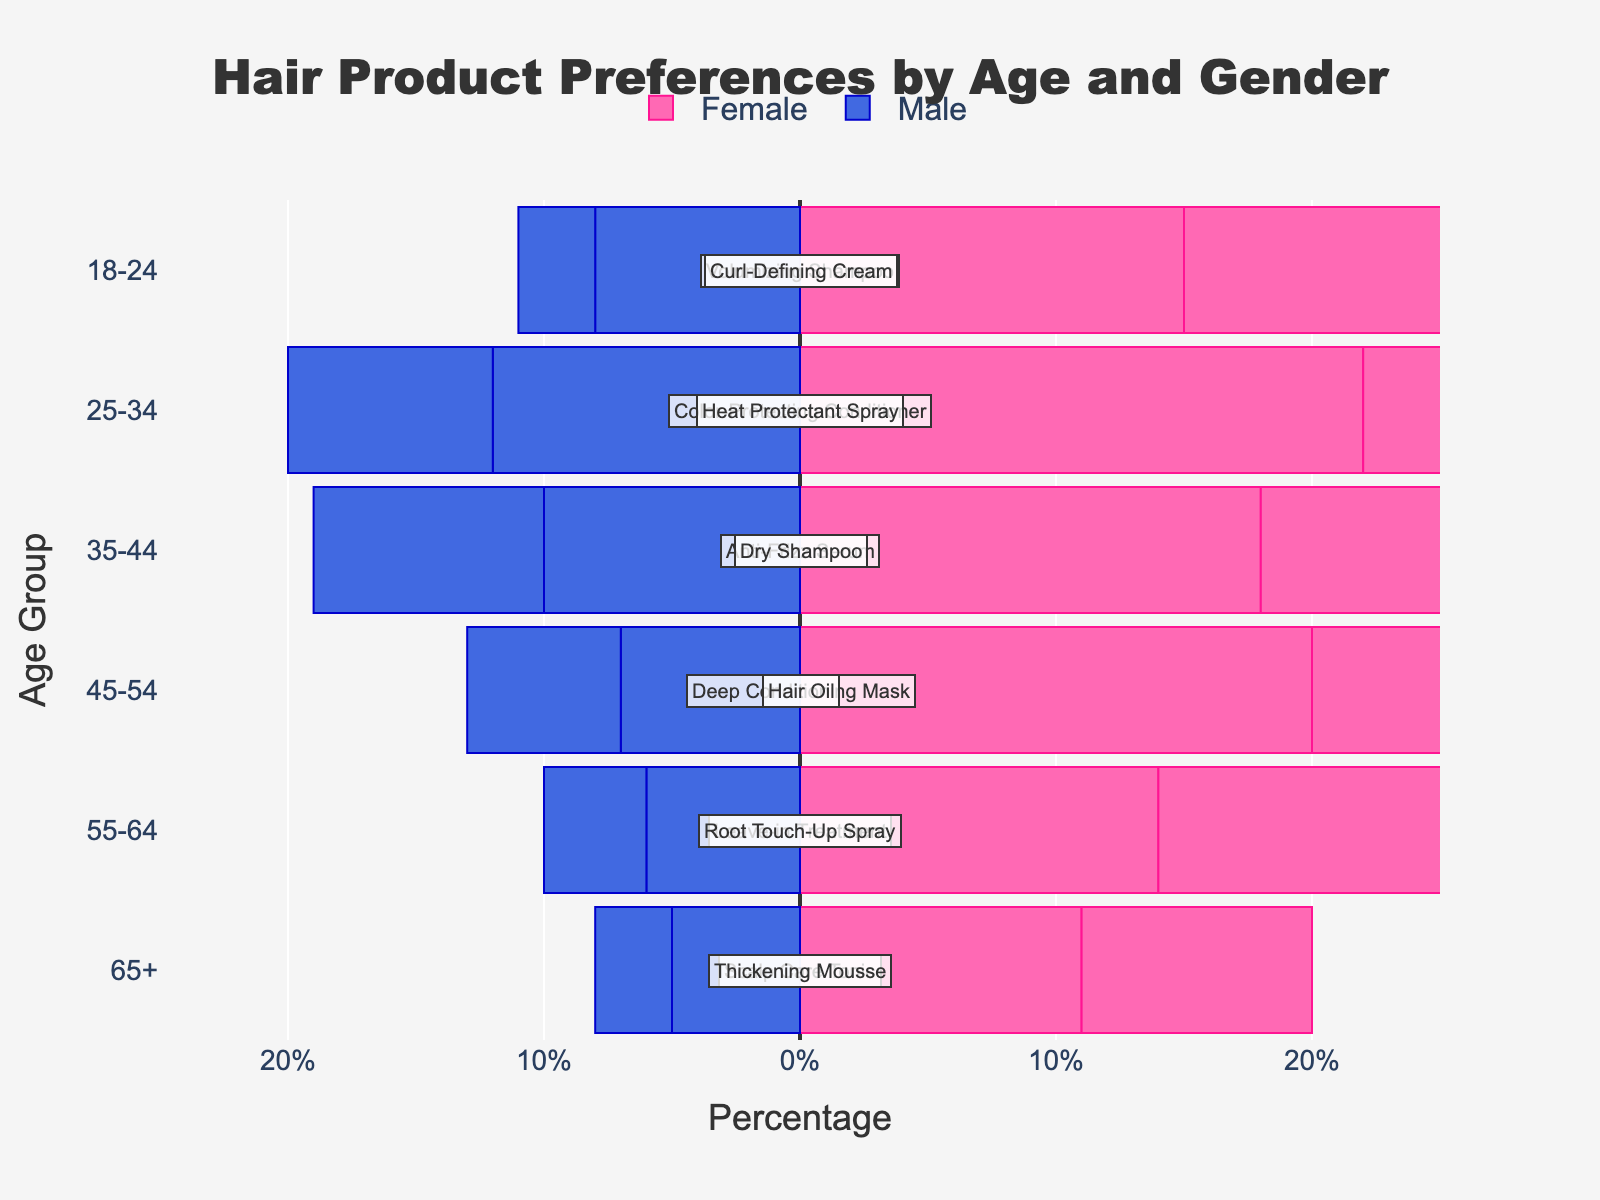what is the most popular product type for the age group 25-34? Look at the age group '25-34' and identify the product type with the highest percentage bar. The 'Color-Protecting Conditioner' is the one with the highest combined preference.
Answer: Color-Protecting Conditioner What age group has the highest percentage of males using Heat Protectant Spray? Look at the percentage bar for males using Heat Protectant Spray and identify the highest age group. The '25-34' age group has the highest percentage for this product.
Answer: 25-34 What is the difference in the percentage of females using Volumizing Shampoo and Root Touch-Up Spray in the 18-24 age group? Compare the percentage bar for females using Volumizing Shampoo and Root Touch-Up Spray for the '18-24' age group. The difference is calculated as 15% (Volumizing Shampoo) - 12% (Root Touch-Up Spray) = 3%.
Answer: 3% Which gender prefers Deep Conditioning Mask more in the 45-54 age group? Compare the percentages of males and females using Deep Conditioning Mask in the 45-54 age group. Females use Deep Conditioning Mask more than males (20% vs. 7%).
Answer: Female Which product type has the smallest percentage difference between males and females in the 55-64 age group? Calculate the absolute difference between male and female percentages for each product type in the 55-64 age group. Root Touch-Up Spray has the smallest difference:
Answer: Root Touch-Up Spray What is the total percentage of customers (both males and females) in the 35-44 age group who prefer Dry Shampoo? Sum the percentages of both males and females for Dry Shampoo in the 35-44 age group. The sum is 16% (females) + 9% (males) = 25%.
Answer: 25% Which age group has the highest female preference for Anti-Frizz Serum? Identify the age group with the highest percentage bar for females using Anti-Frizz Serum. The '35-44' age group has the highest female preference.
Answer: 35-44 What is the combined preference (both genders) for Scalp Care Tonic in the 65+ age group? Add up the percentages for both females and males using Scalp Care Tonic in the 65+ age group. The combined preference is 11% (females) + 5% (males) = 16%.
Answer: 16% How much more do females prefer Curl-Defining Cream in the 18-24 age group compared to males? Subtract the percentage of males using Curl-Defining Cream from the percentage of females in the 18-24 age group. The difference is 12% (females) - 3% (males) = 9%.
Answer: 9% Which age group has the highest total preference (both genders combined) for any product type? Identify the age group with the highest sum of preferences by adding up the percentages for both genders for each age group. The 25-34 age group has the highest total preference.
Answer: 25-34 